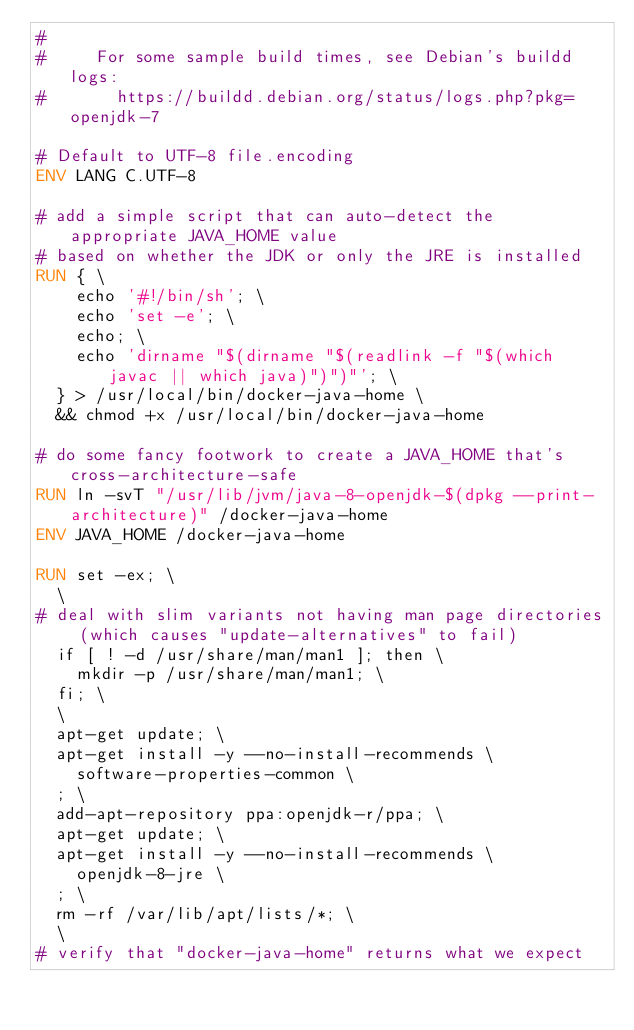<code> <loc_0><loc_0><loc_500><loc_500><_Dockerfile_>#
#     For some sample build times, see Debian's buildd logs:
#       https://buildd.debian.org/status/logs.php?pkg=openjdk-7

# Default to UTF-8 file.encoding
ENV LANG C.UTF-8

# add a simple script that can auto-detect the appropriate JAVA_HOME value
# based on whether the JDK or only the JRE is installed
RUN { \
		echo '#!/bin/sh'; \
		echo 'set -e'; \
		echo; \
		echo 'dirname "$(dirname "$(readlink -f "$(which javac || which java)")")"'; \
	} > /usr/local/bin/docker-java-home \
	&& chmod +x /usr/local/bin/docker-java-home

# do some fancy footwork to create a JAVA_HOME that's cross-architecture-safe
RUN ln -svT "/usr/lib/jvm/java-8-openjdk-$(dpkg --print-architecture)" /docker-java-home
ENV JAVA_HOME /docker-java-home

RUN set -ex; \
	\
# deal with slim variants not having man page directories (which causes "update-alternatives" to fail)
	if [ ! -d /usr/share/man/man1 ]; then \
		mkdir -p /usr/share/man/man1; \
	fi; \
	\
	apt-get update; \
	apt-get install -y --no-install-recommends \
		software-properties-common \
	; \
	add-apt-repository ppa:openjdk-r/ppa; \
	apt-get update; \
	apt-get install -y --no-install-recommends \
		openjdk-8-jre \
	; \
	rm -rf /var/lib/apt/lists/*; \
	\
# verify that "docker-java-home" returns what we expect</code> 